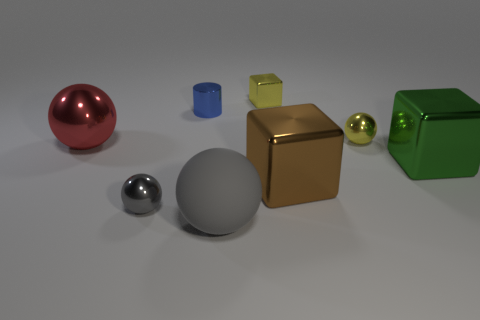What is the color of the rubber sphere?
Offer a very short reply. Gray. Are there any tiny spheres right of the small gray sphere?
Provide a short and direct response. Yes. Is the color of the small cylinder the same as the small cube?
Your response must be concise. No. How many metallic things are the same color as the small shiny cube?
Give a very brief answer. 1. How big is the ball on the right side of the thing that is behind the blue shiny cylinder?
Give a very brief answer. Small. The gray matte thing is what shape?
Provide a succinct answer. Sphere. There is a large sphere that is behind the gray rubber object; what is its material?
Offer a very short reply. Metal. What is the color of the small sphere that is in front of the tiny metal ball that is on the right side of the large metal block to the left of the green cube?
Ensure brevity in your answer.  Gray. What color is the cube that is the same size as the brown object?
Provide a succinct answer. Green. What number of shiny objects are cylinders or large balls?
Give a very brief answer. 2. 